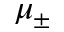<formula> <loc_0><loc_0><loc_500><loc_500>\mu _ { \pm }</formula> 